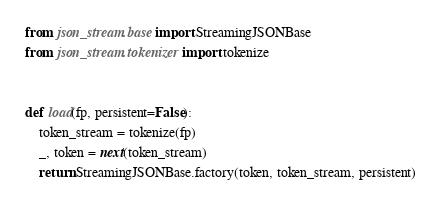<code> <loc_0><loc_0><loc_500><loc_500><_Python_>from json_stream.base import StreamingJSONBase
from json_stream.tokenizer import tokenize


def load(fp, persistent=False):
    token_stream = tokenize(fp)
    _, token = next(token_stream)
    return StreamingJSONBase.factory(token, token_stream, persistent)
</code> 